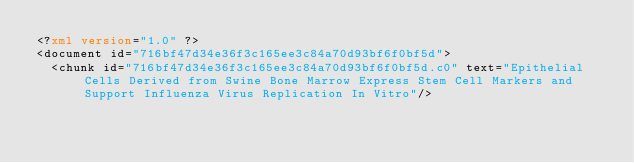<code> <loc_0><loc_0><loc_500><loc_500><_XML_><?xml version="1.0" ?>
<document id="716bf47d34e36f3c165ee3c84a70d93bf6f0bf5d">
  <chunk id="716bf47d34e36f3c165ee3c84a70d93bf6f0bf5d.c0" text="Epithelial Cells Derived from Swine Bone Marrow Express Stem Cell Markers and Support Influenza Virus Replication In Vitro"/></code> 